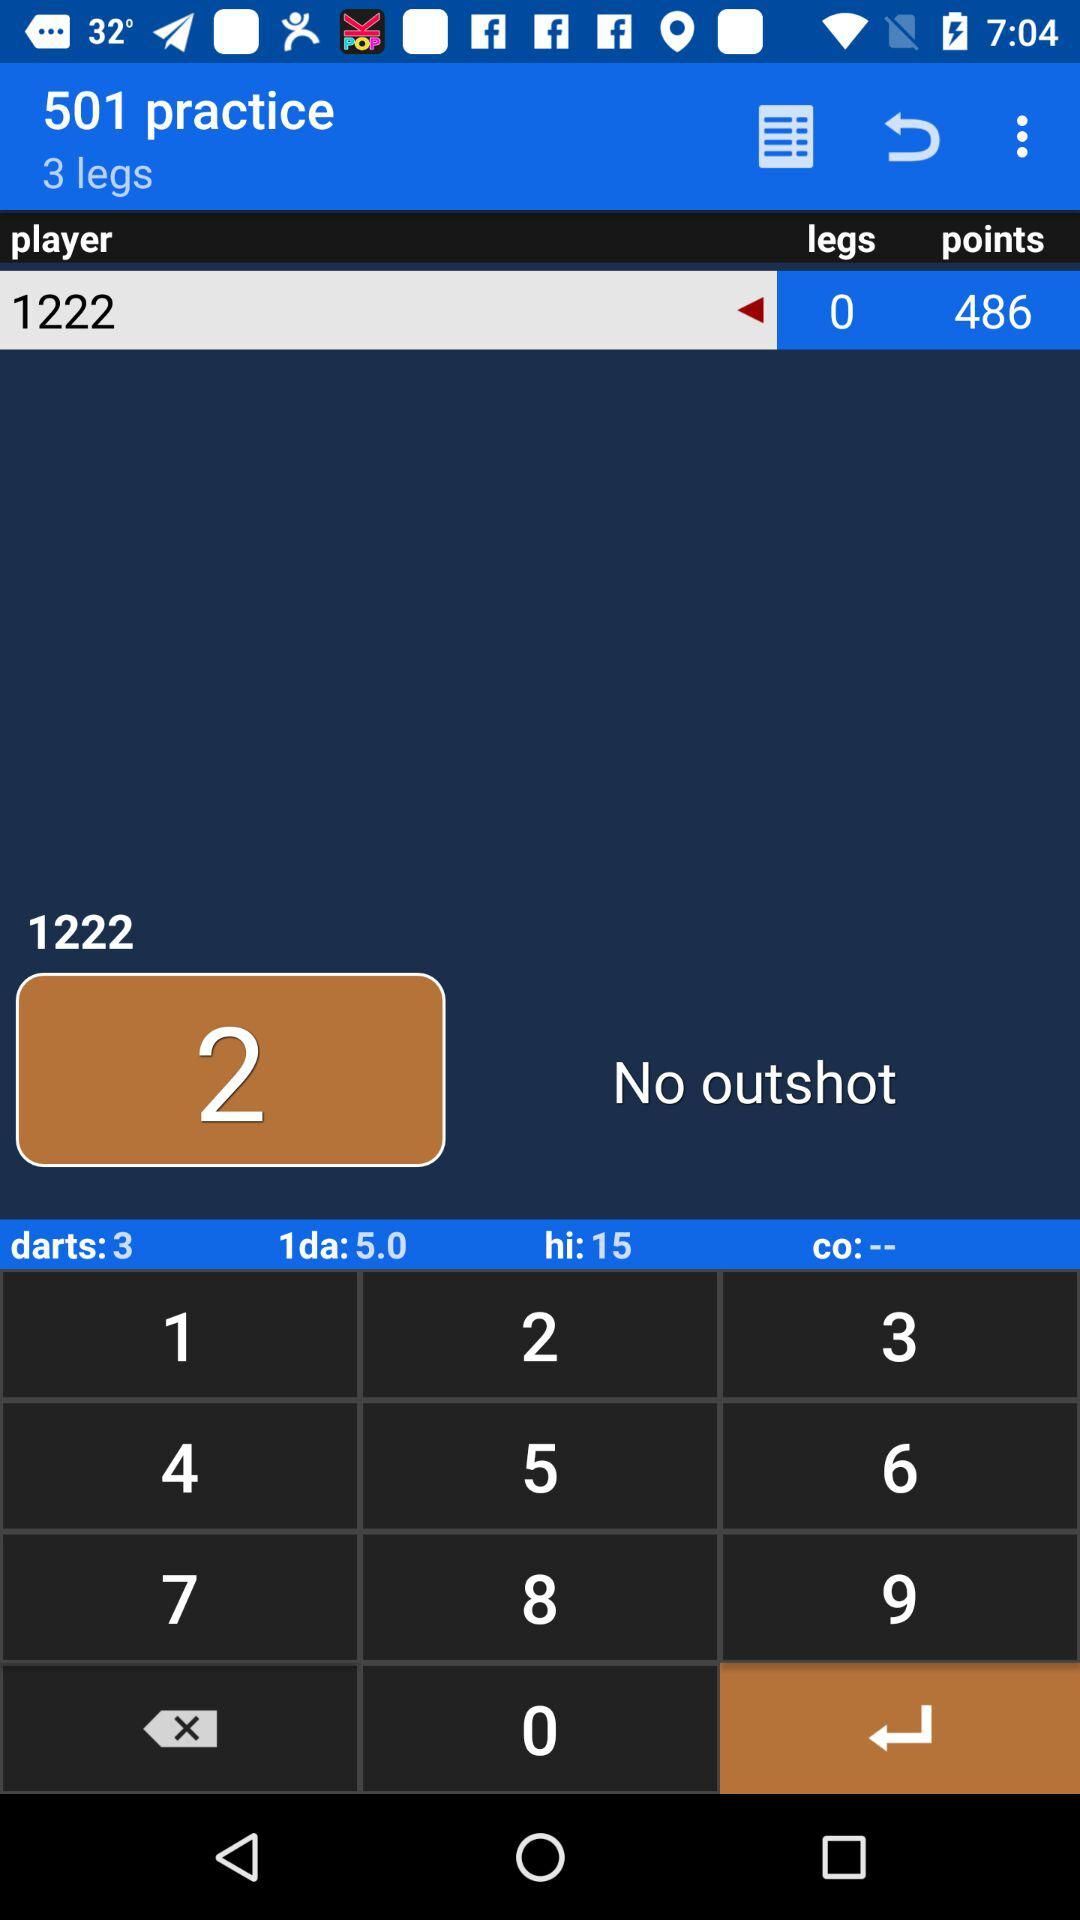How many practices are there? There are 501 practices. 